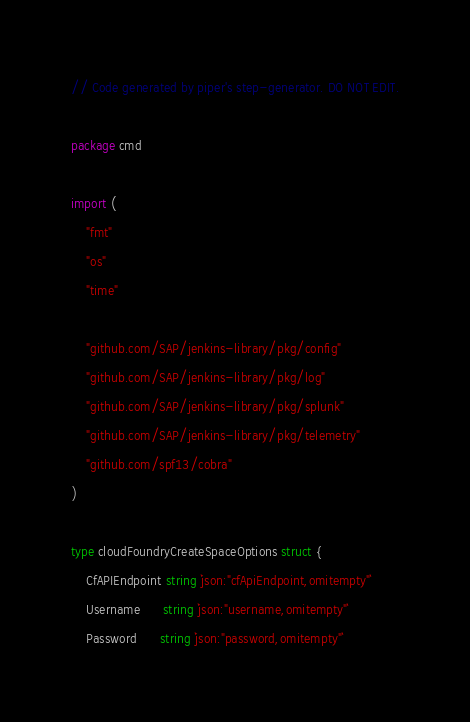<code> <loc_0><loc_0><loc_500><loc_500><_Go_>// Code generated by piper's step-generator. DO NOT EDIT.

package cmd

import (
	"fmt"
	"os"
	"time"

	"github.com/SAP/jenkins-library/pkg/config"
	"github.com/SAP/jenkins-library/pkg/log"
	"github.com/SAP/jenkins-library/pkg/splunk"
	"github.com/SAP/jenkins-library/pkg/telemetry"
	"github.com/spf13/cobra"
)

type cloudFoundryCreateSpaceOptions struct {
	CfAPIEndpoint string `json:"cfApiEndpoint,omitempty"`
	Username      string `json:"username,omitempty"`
	Password      string `json:"password,omitempty"`</code> 